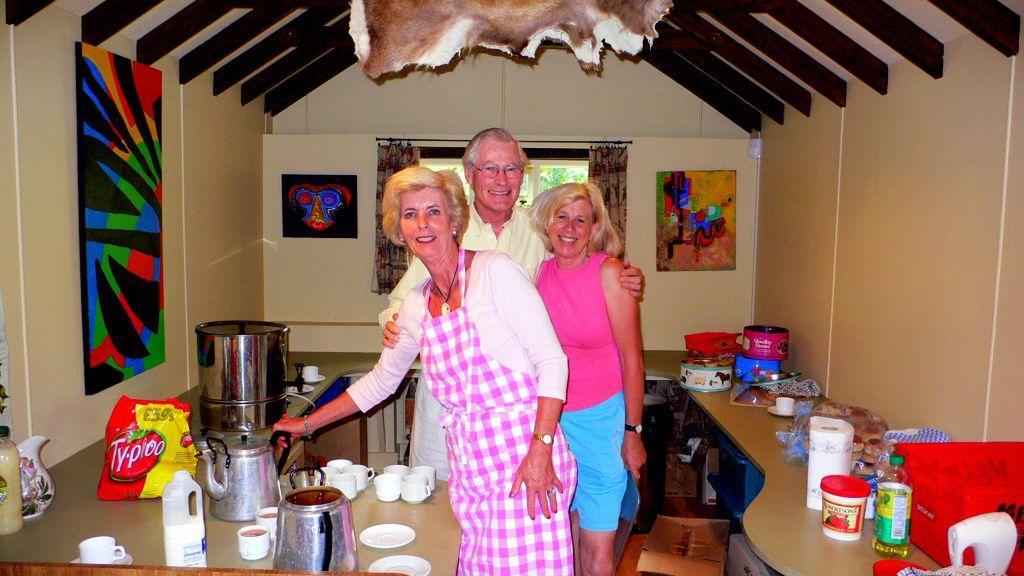How would you summarize this image in a sentence or two? This image is taken indoors. In the background there is a wall with a few paintings. There is a window and there are two curtains. At the top of the image there is a roof and there is an object. In the middle of the image a man and two women are standing. They are with smiling faces. On the left and right sides of the image there are two kitchen platforms with tissue rolls, bottles, boxes, cups, saucers, kettles and many things on them. 